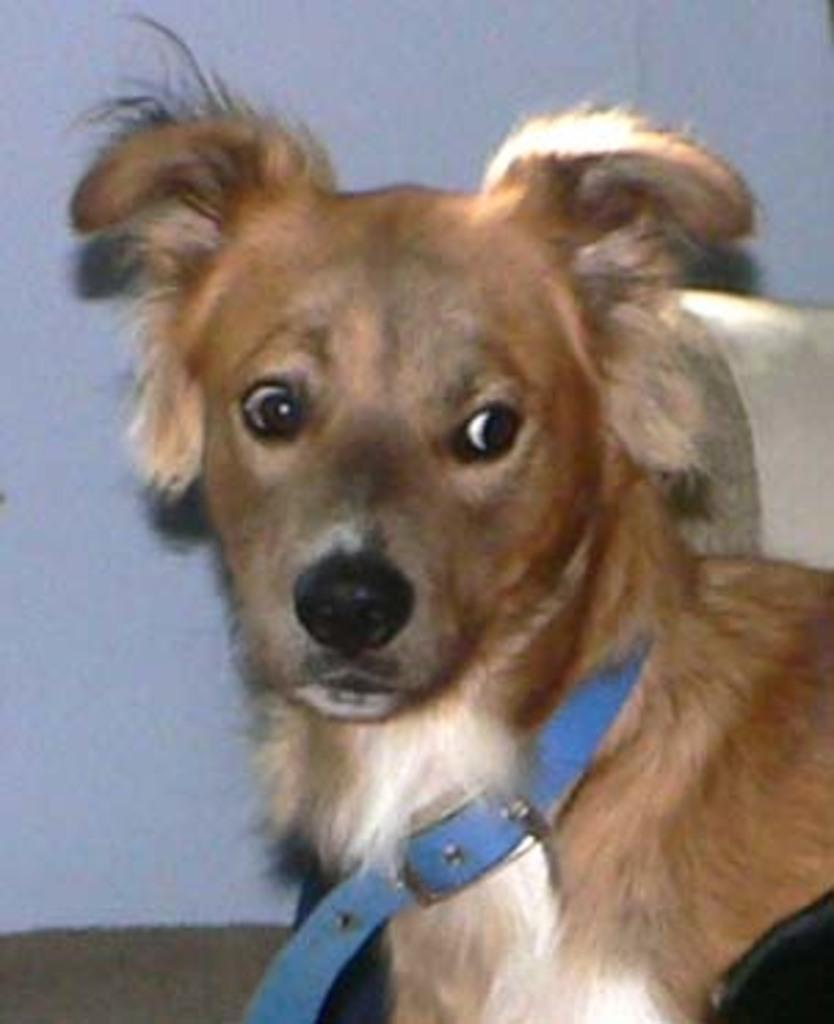What type of animal is in the image? There is a dog in the image. What is the dog wearing? The dog is wearing a belt. What can be seen in the background of the image? There is a wall in the background of the image. What type of grape is the dog eating in the image? There is no grape present in the image, and the dog is not eating anything. 